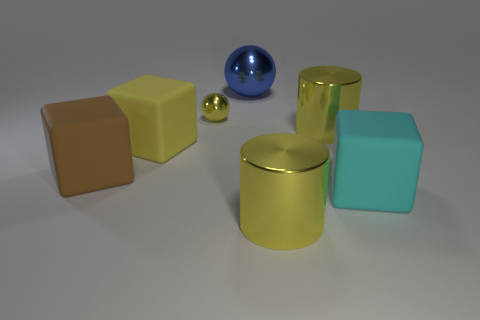Is there anything else that is the same size as the yellow shiny ball?
Your response must be concise. No. Do the cylinder behind the cyan matte cube and the yellow sphere that is right of the large yellow rubber thing have the same size?
Ensure brevity in your answer.  No. The other thing that is the same shape as the big blue shiny thing is what color?
Provide a succinct answer. Yellow. Is the number of blocks on the right side of the large blue shiny object greater than the number of big yellow matte cubes that are behind the yellow metallic ball?
Your response must be concise. Yes. How big is the block that is right of the yellow metallic thing that is left of the shiny ball that is behind the small sphere?
Keep it short and to the point. Large. Does the small sphere have the same material as the large sphere right of the tiny yellow thing?
Offer a very short reply. Yes. Do the big blue object and the yellow matte thing have the same shape?
Provide a short and direct response. No. How many other things are there of the same material as the brown object?
Make the answer very short. 2. What number of other big objects are the same shape as the big yellow matte thing?
Ensure brevity in your answer.  2. What is the color of the object that is both left of the cyan object and in front of the large brown matte block?
Offer a terse response. Yellow. 